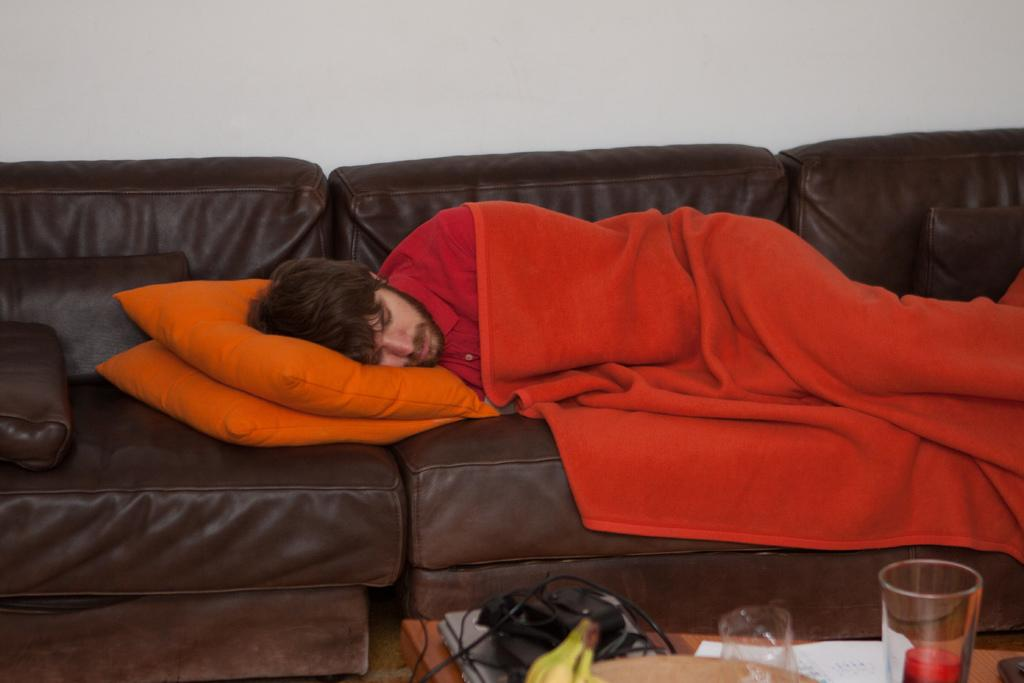What is the person in the image doing? The person is sleeping on a sofa. What is covering the person while they sleep? The person has a blanket on them. What is supporting the person's head while they sleep? There are pillows under the person's head. What can be seen in the image besides the person sleeping? There is a table in the image. What is on the table in the image? The table has many things on it. What type of lettuce is being sold at the market in the image? There is no market or lettuce present in the image; it features a person sleeping on a sofa with a blanket and pillows. 